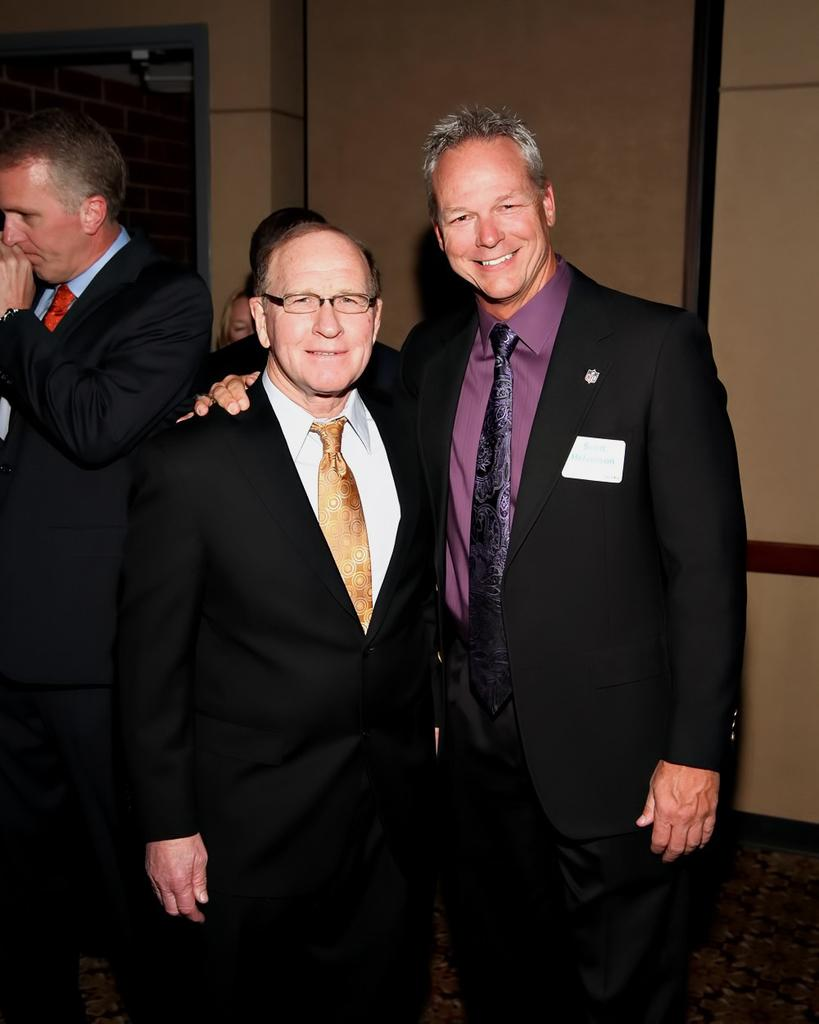How many people are in the image? There are two people standing in the foreground of the image. What are the people wearing? The people are wearing suits. Can you describe any architectural features in the image? Yes, there is a door in the top left corner of the image. How many waves can be seen crashing on the shore in the image? There are no waves or shore visible in the image; it features two people wearing suits and a door. What type of riddle is depicted on the wall behind the people in the image? There is no riddle depicted on the wall behind the people in the image. 